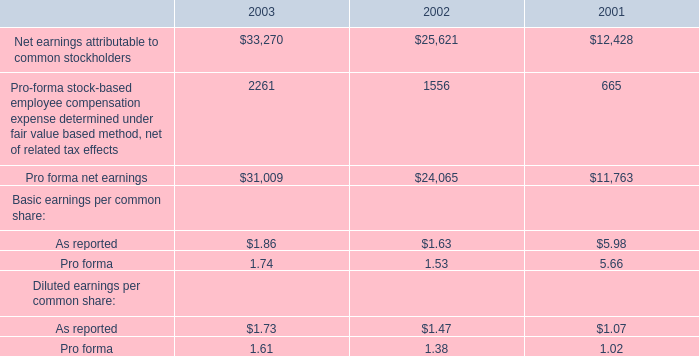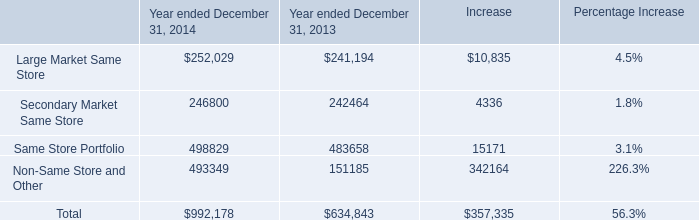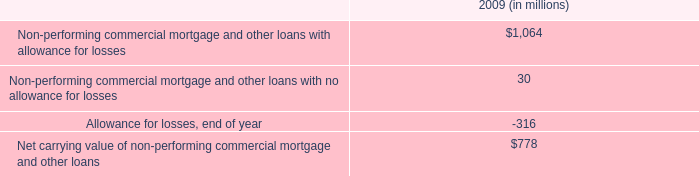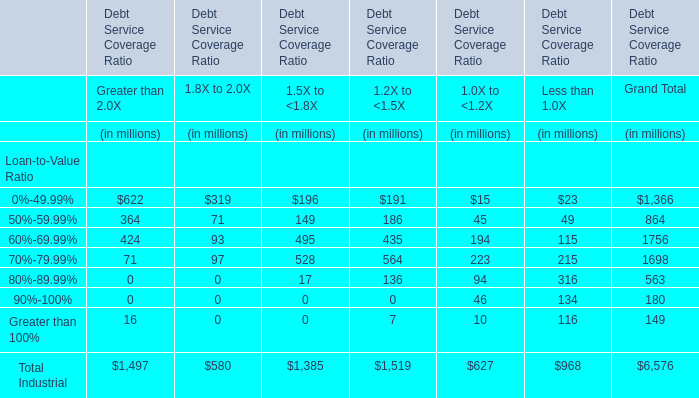What is the average amount of Secondary Market Same Store of Year ended December 31, 2013, and Pro forma net earnings of 2002 ? 
Computations: ((242464.0 + 24065.0) / 2)
Answer: 133264.5. 